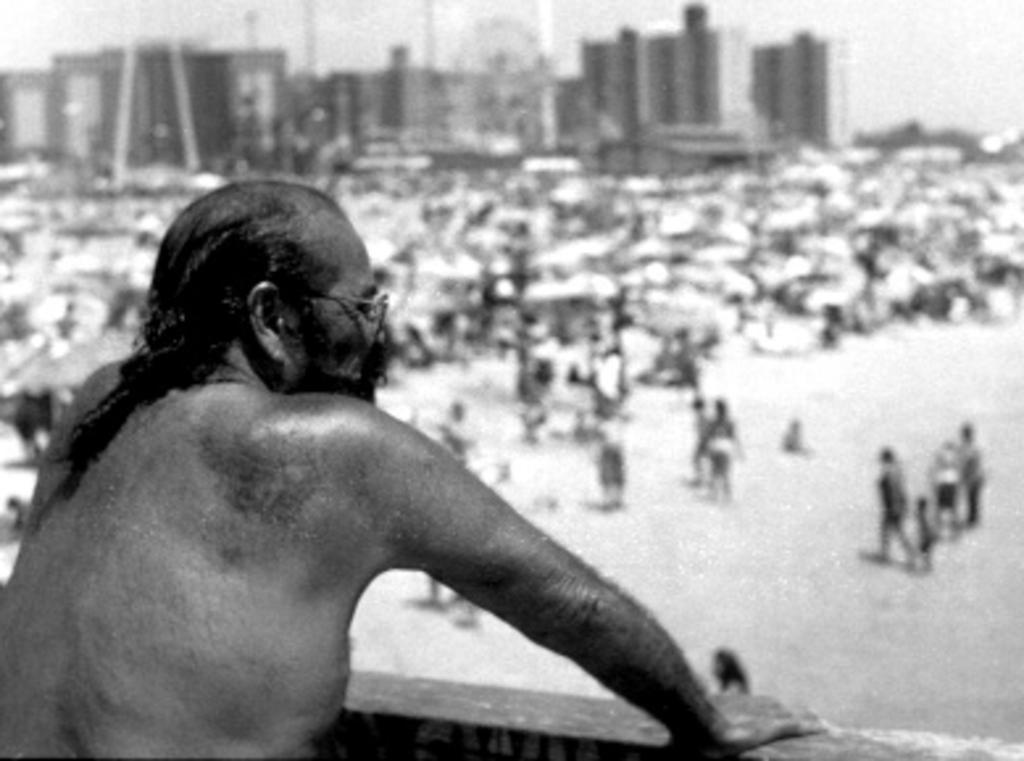Describe this image in one or two sentences. In this image I can see a man is wearing spectacles. In the background I can see people, buildings and the sky. This picture is black and white in color. 